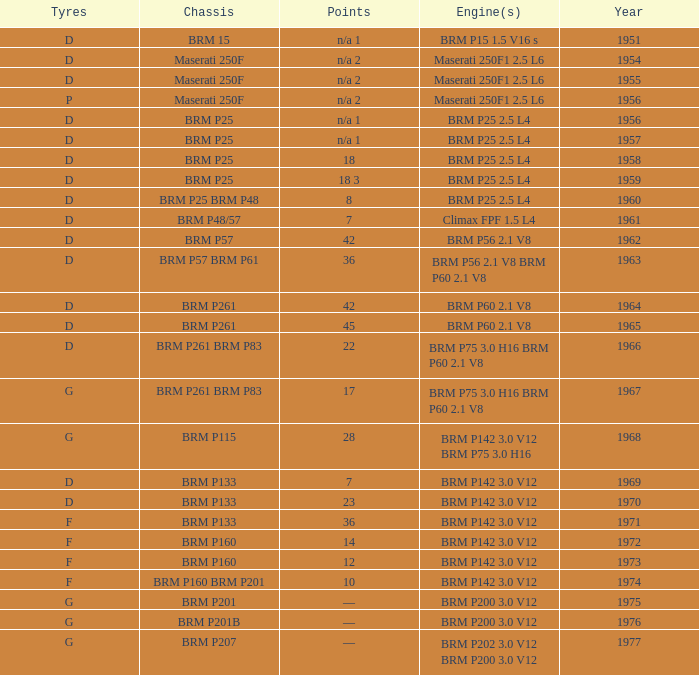Name the sum of year for engine of brm p202 3.0 v12 brm p200 3.0 v12 1977.0. 